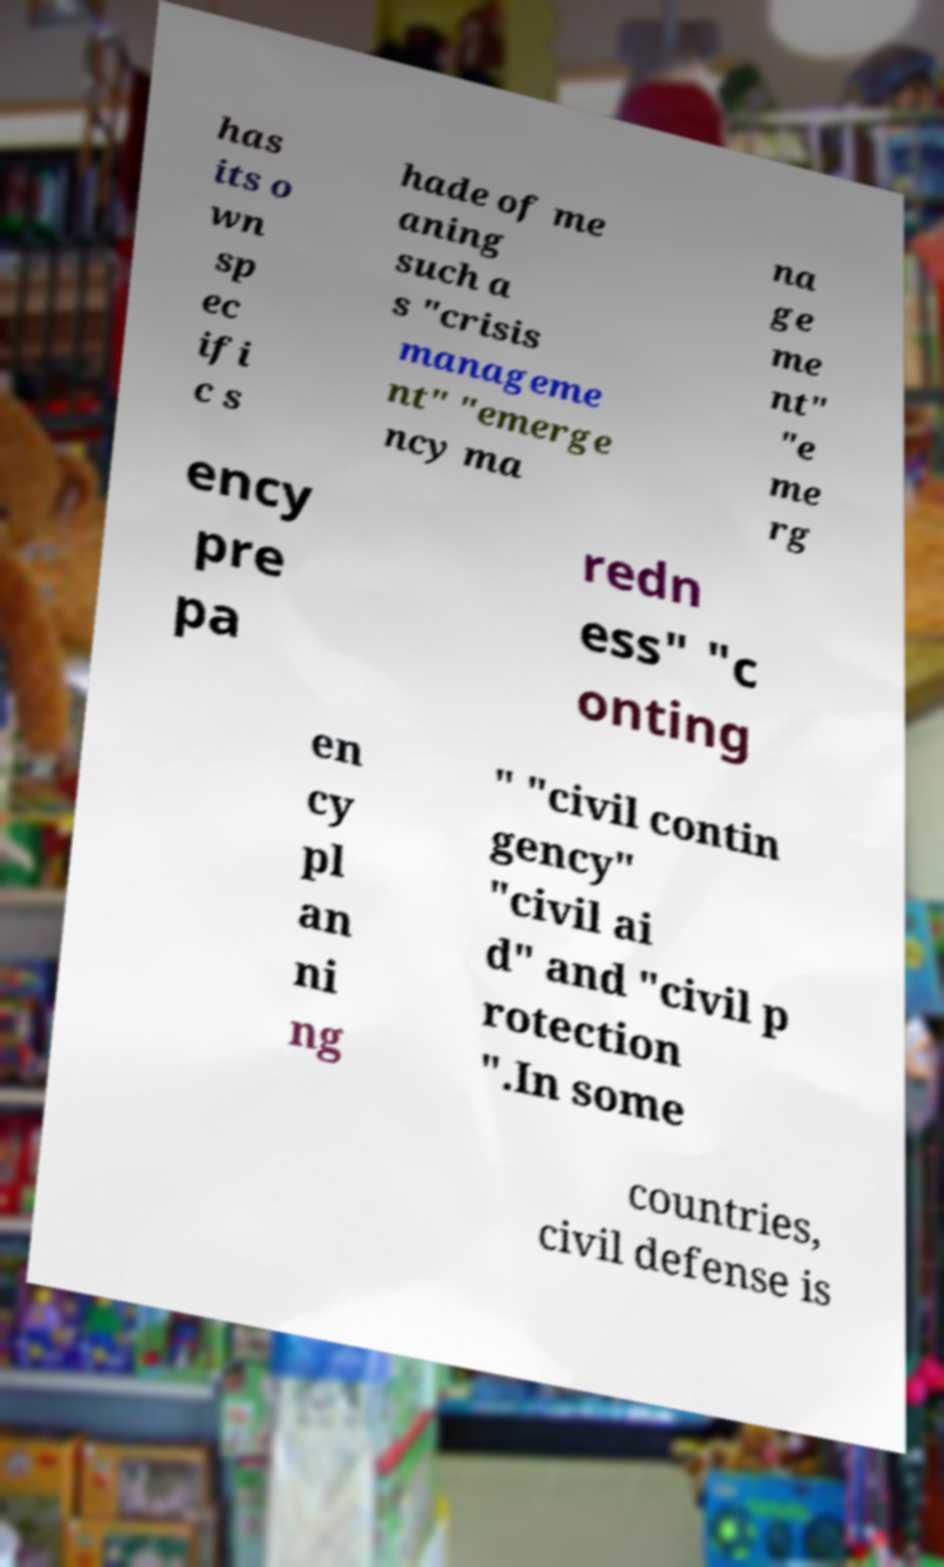Please identify and transcribe the text found in this image. has its o wn sp ec ifi c s hade of me aning such a s "crisis manageme nt" "emerge ncy ma na ge me nt" "e me rg ency pre pa redn ess" "c onting en cy pl an ni ng " "civil contin gency" "civil ai d" and "civil p rotection ".In some countries, civil defense is 